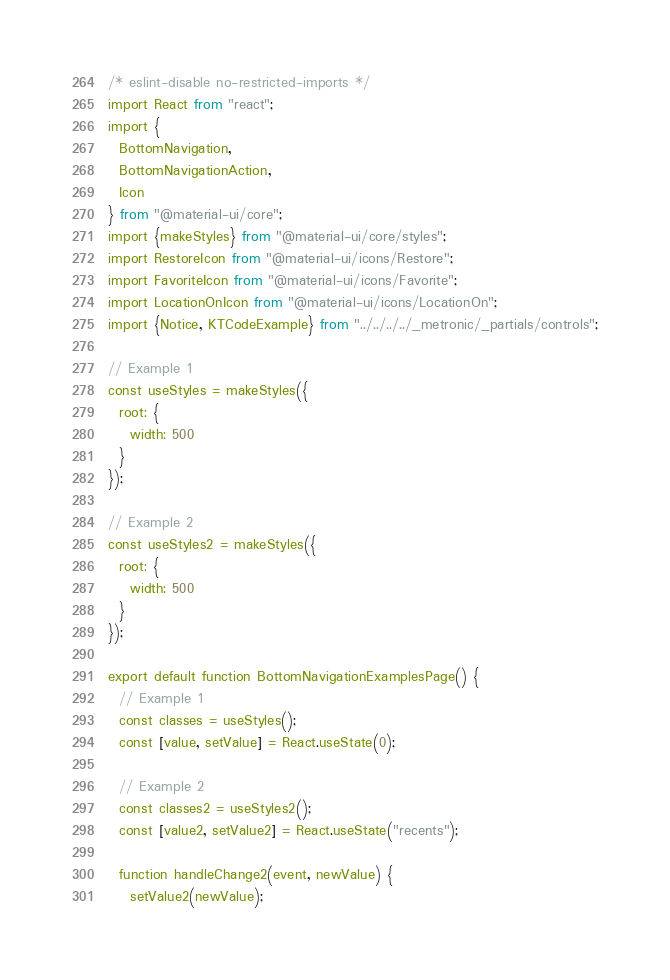<code> <loc_0><loc_0><loc_500><loc_500><_JavaScript_>/* eslint-disable no-restricted-imports */
import React from "react";
import {
  BottomNavigation,
  BottomNavigationAction,
  Icon
} from "@material-ui/core";
import {makeStyles} from "@material-ui/core/styles";
import RestoreIcon from "@material-ui/icons/Restore";
import FavoriteIcon from "@material-ui/icons/Favorite";
import LocationOnIcon from "@material-ui/icons/LocationOn";
import {Notice, KTCodeExample} from "../../../../_metronic/_partials/controls";

// Example 1
const useStyles = makeStyles({
  root: {
    width: 500
  }
});

// Example 2
const useStyles2 = makeStyles({
  root: {
    width: 500
  }
});

export default function BottomNavigationExamplesPage() {
  // Example 1
  const classes = useStyles();
  const [value, setValue] = React.useState(0);

  // Example 2
  const classes2 = useStyles2();
  const [value2, setValue2] = React.useState("recents");

  function handleChange2(event, newValue) {
    setValue2(newValue);</code> 